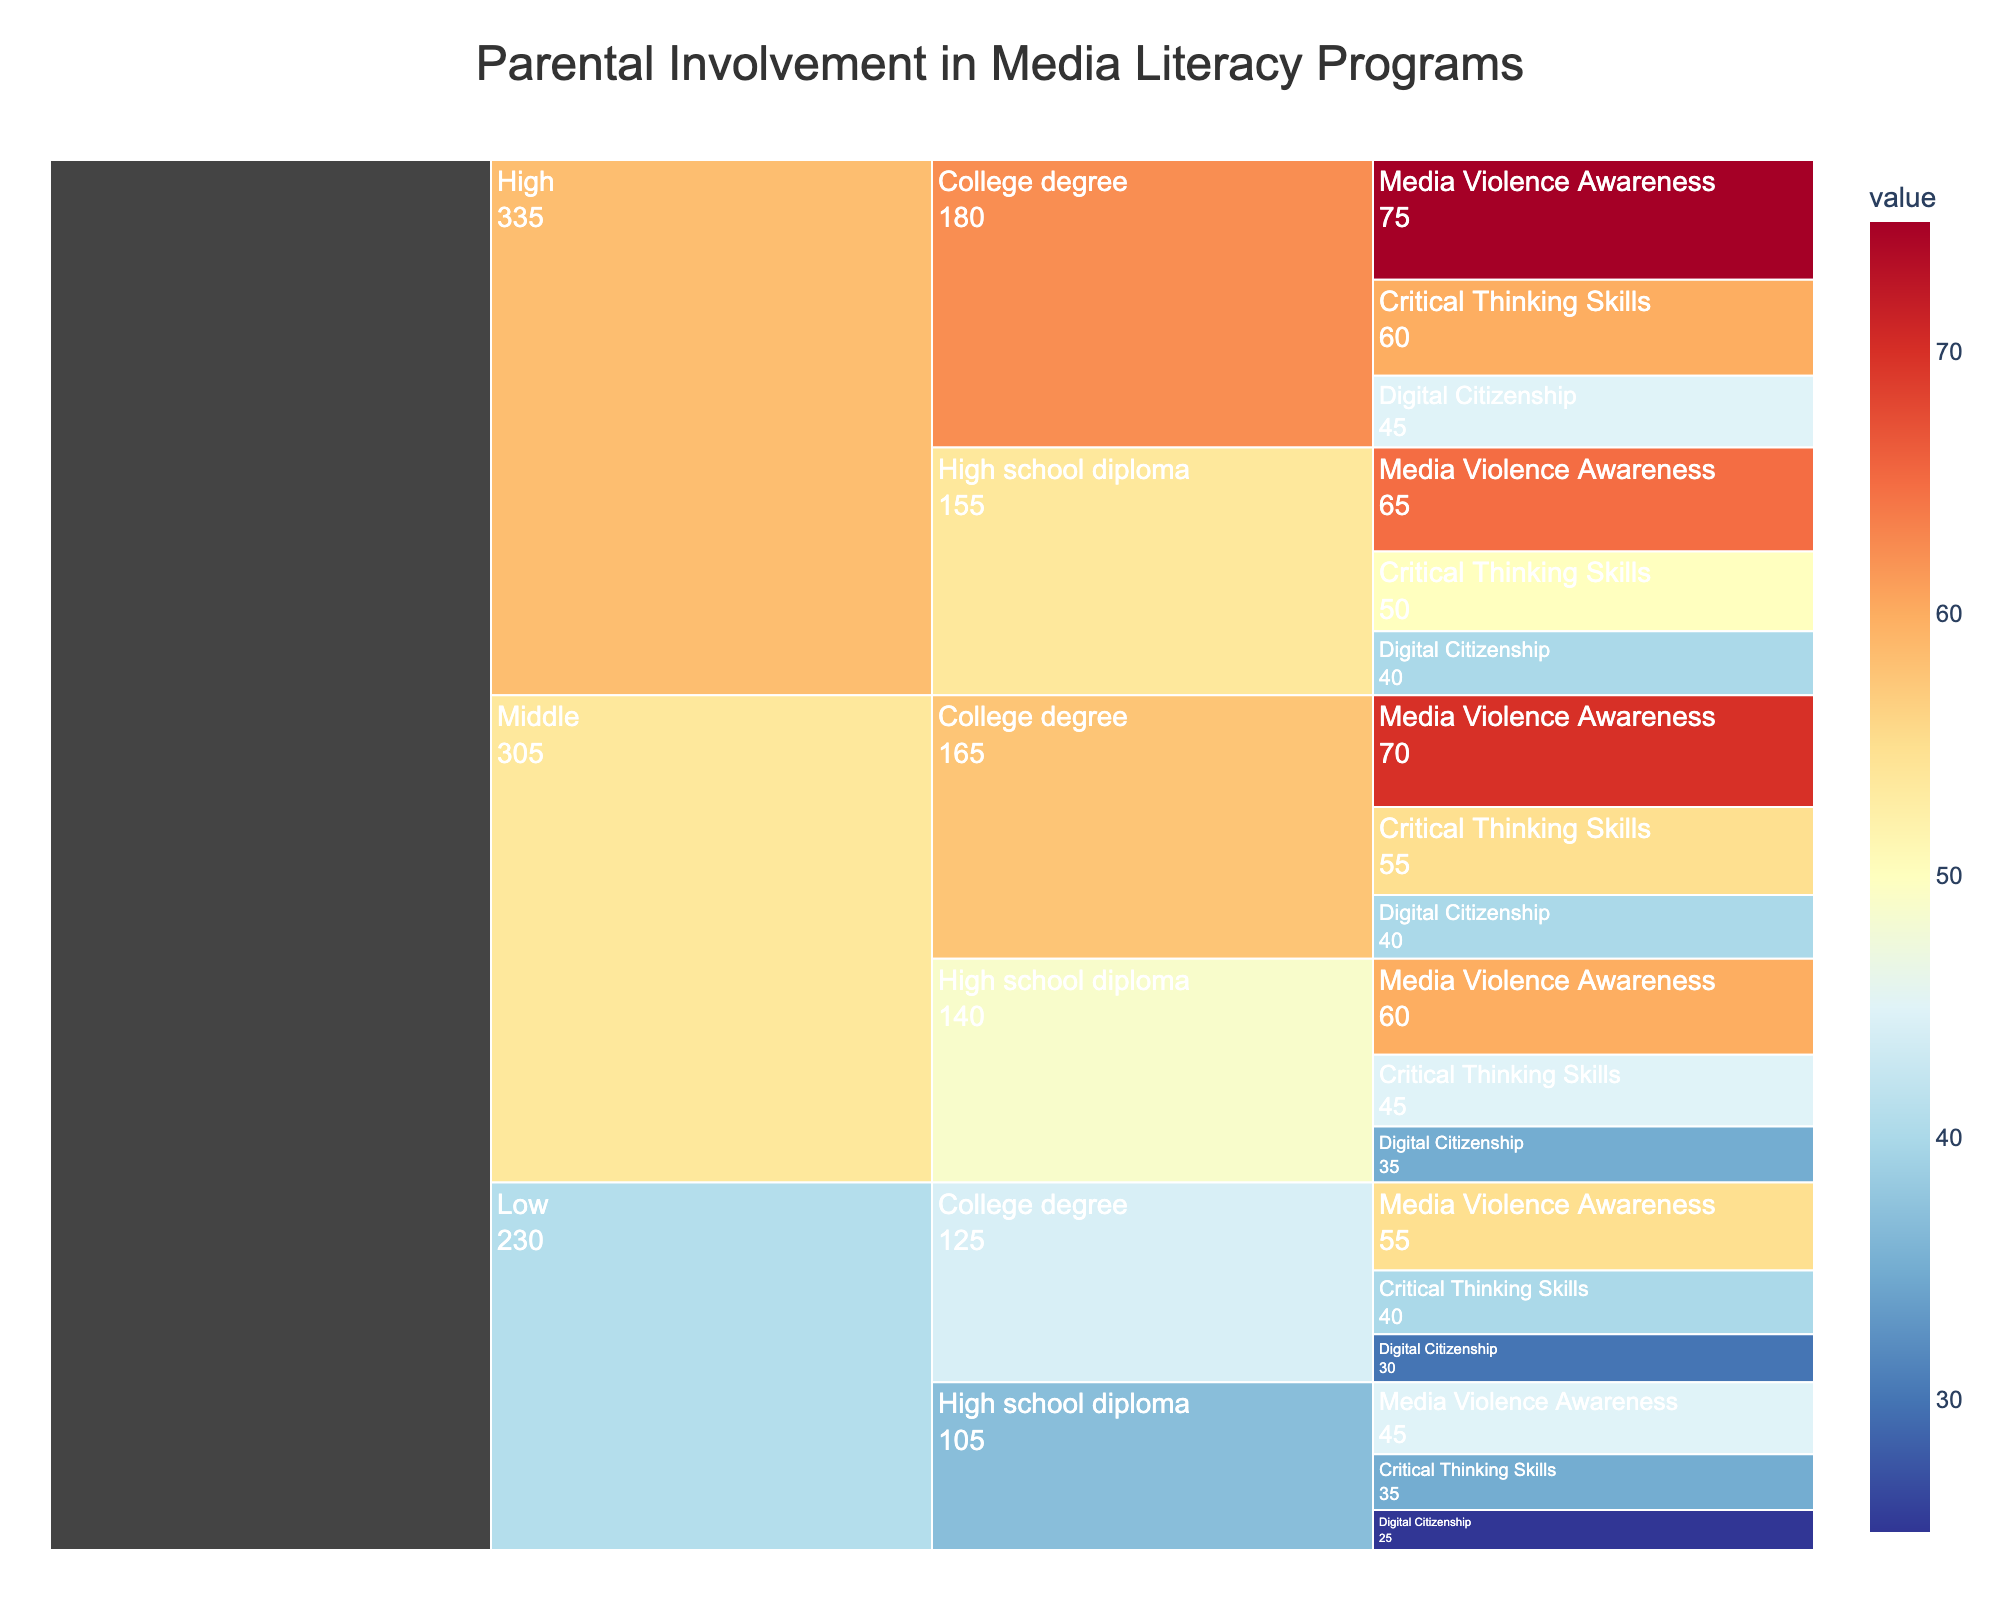What is the title of the chart? The title is usually presented at the top of the chart and serves as a brief description of what the figure is about. Look at the top of the figure for the title.
Answer: Parental Involvement in Media Literacy Programs Which socioeconomic status category has the highest participation rate in Media Violence Awareness programs? Referring to the icicle chart, identify the branch labeled "Media Violence Awareness" under each socioeconomic status. Compare the participation rates to determine the highest.
Answer: High What is the participation rate for parents with a high school diploma in the "Critical Thinking Skills" program in the middle socioeconomic status? Navigate through the hierarchy in the chart: Middle > High school diploma > Critical Thinking Skills. The participation rate is shown within the block.
Answer: 45% Compare the participation rates of parents with college degrees in "Digital Citizenship" across all socioeconomic statuses. Which socioeconomic status has the lowest rate? Follow the hierarchy: College degree > Digital Citizenship under each socioeconomic status. Compare the values to find the lowest one.
Answer: Low What is the average participation rate for the "Media Violence Awareness" program across all socioeconomic statuses? Locate the participation rates for "Media Violence Awareness" under High, Middle, and Low socioeconomic statuses. Sum the rates (75 + 70 + 55) and divide by 3.
Answer: 66.67% Which program has the lowest participation rate for parents with a college degree in the high socioeconomic status? Under the high socioeconomic status and college degree category, check the participation rates for each program and identify the lowest one.
Answer: Digital Citizenship Calculate the difference in participation rates in "Critical Thinking Skills" between parents with high school diplomas in the high and low socioeconomic statuses. Find the participation rates for "Critical Thinking Skills" in the high and low socioeconomic statuses (High: 50, Low: 35), then calculate the difference (50 - 35).
Answer: 15% Which educational background has a higher participation rate in the "Media Violence Awareness" program within the low socioeconomic status? Examine the "Media Violence Awareness" rates under low socioeconomic status, compare College degree and High school diploma.
Answer: High school diploma What is the combined participation rate for the "Digital Citizenship" program across all educational backgrounds in the middle socioeconomic status? Add the rates for Digital Citizenship under middle socioeconomic status for both College degree and High school diploma (40 + 35).
Answer: 75% Which program shows the largest difference in participation rates between the highest and middle socioeconomic statuses for parents with a college degree? Check the participation rates for each program under High and Middle socioeconomic statuses with a college degree. Calculate the differences (75-70, 60-55, 45-40) and find the largest one.
Answer: Media Violence Awareness 